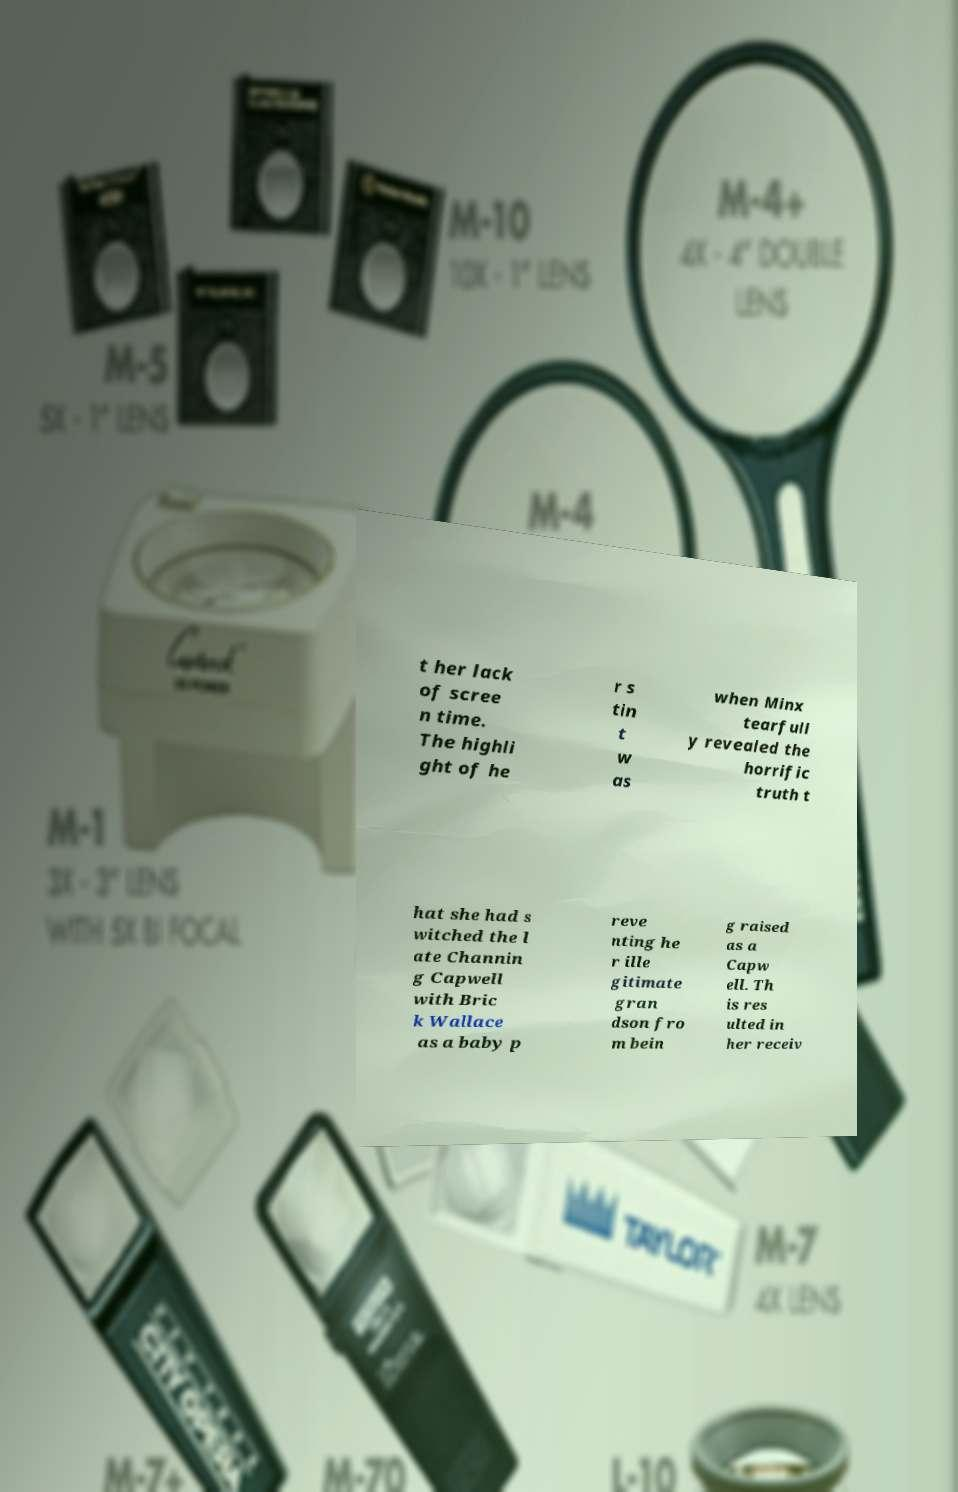Can you read and provide the text displayed in the image?This photo seems to have some interesting text. Can you extract and type it out for me? t her lack of scree n time. The highli ght of he r s tin t w as when Minx tearfull y revealed the horrific truth t hat she had s witched the l ate Channin g Capwell with Bric k Wallace as a baby p reve nting he r ille gitimate gran dson fro m bein g raised as a Capw ell. Th is res ulted in her receiv 